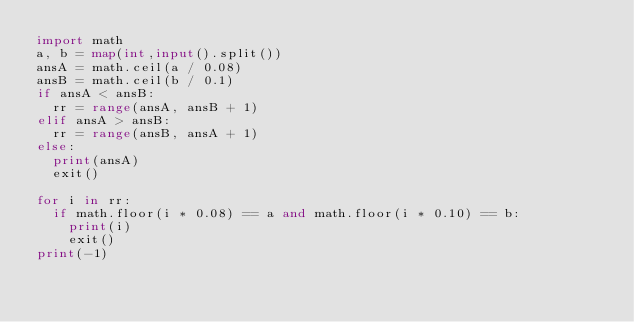<code> <loc_0><loc_0><loc_500><loc_500><_Python_>import math
a, b = map(int,input().split())
ansA = math.ceil(a / 0.08)
ansB = math.ceil(b / 0.1)
if ansA < ansB:
  rr = range(ansA, ansB + 1)
elif ansA > ansB:
  rr = range(ansB, ansA + 1)
else:
  print(ansA)
  exit()
  
for i in rr:
  if math.floor(i * 0.08) == a and math.floor(i * 0.10) == b:
    print(i)
    exit()
print(-1)</code> 